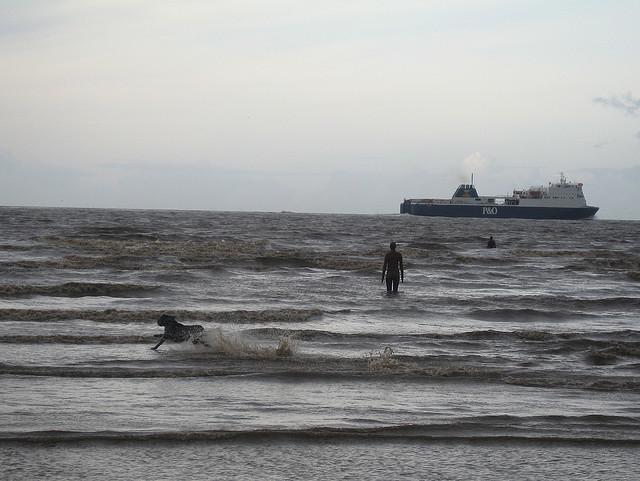How many boats are there?
Give a very brief answer. 1. How many orange slices can you see?
Give a very brief answer. 0. 